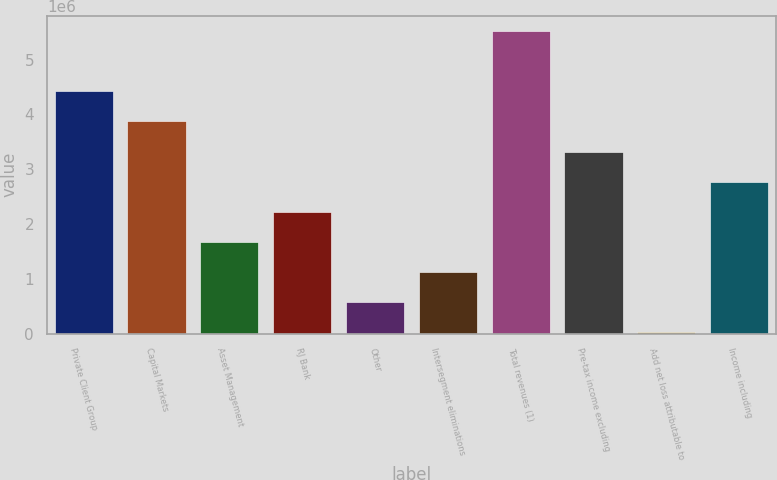<chart> <loc_0><loc_0><loc_500><loc_500><bar_chart><fcel>Private Client Group<fcel>Capital Markets<fcel>Asset Management<fcel>RJ Bank<fcel>Other<fcel>Intersegment eliminations<fcel>Total revenues (1)<fcel>Pre-tax income excluding<fcel>Add net loss attributable to<fcel>Income including<nl><fcel>4.42093e+06<fcel>3.87122e+06<fcel>1.67239e+06<fcel>2.2221e+06<fcel>572979<fcel>1.12269e+06<fcel>5.52034e+06<fcel>3.32152e+06<fcel>23272<fcel>2.77181e+06<nl></chart> 